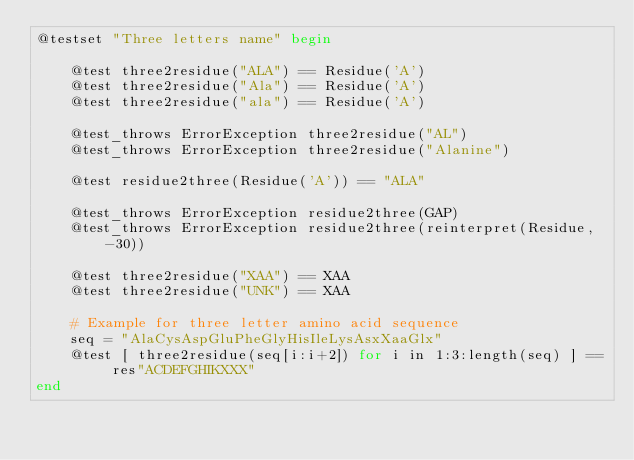Convert code to text. <code><loc_0><loc_0><loc_500><loc_500><_Julia_>@testset "Three letters name" begin

    @test three2residue("ALA") == Residue('A')
    @test three2residue("Ala") == Residue('A')
    @test three2residue("ala") == Residue('A')

    @test_throws ErrorException three2residue("AL")
    @test_throws ErrorException three2residue("Alanine")

    @test residue2three(Residue('A')) == "ALA"

    @test_throws ErrorException residue2three(GAP)
    @test_throws ErrorException residue2three(reinterpret(Residue, -30))

    @test three2residue("XAA") == XAA
    @test three2residue("UNK") == XAA

    # Example for three letter amino acid sequence
    seq = "AlaCysAspGluPheGlyHisIleLysAsxXaaGlx"
    @test [ three2residue(seq[i:i+2]) for i in 1:3:length(seq) ] == res"ACDEFGHIKXXX"
end
</code> 